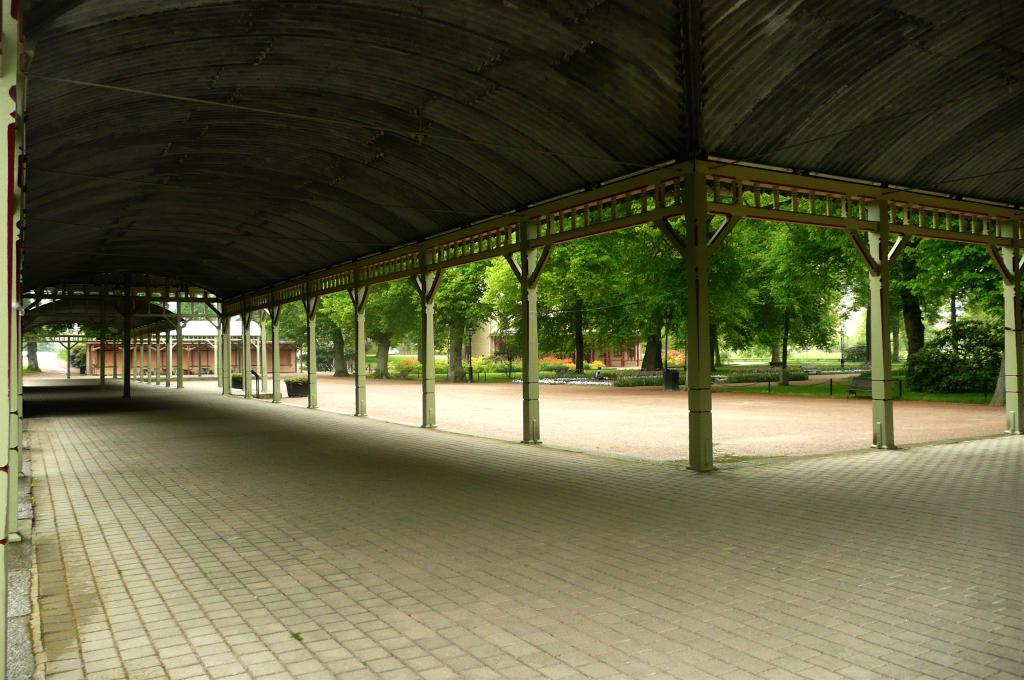What type of surface can be seen in the image? There is a path in the image. What architectural features are present in the image? There are pillars and buildings in the image. What type of vegetation is visible in the image? There is grass in the image. What can be seen in the background of the image? There are trees visible in the background of the image. What is the plot of the story being told in the image? There is no story being told in the image, as it is a static representation of a scene. What is the intended use of the pillars in the image? The image does not provide information about the intended use of the pillars; they are simply depicted as part of the scene. 